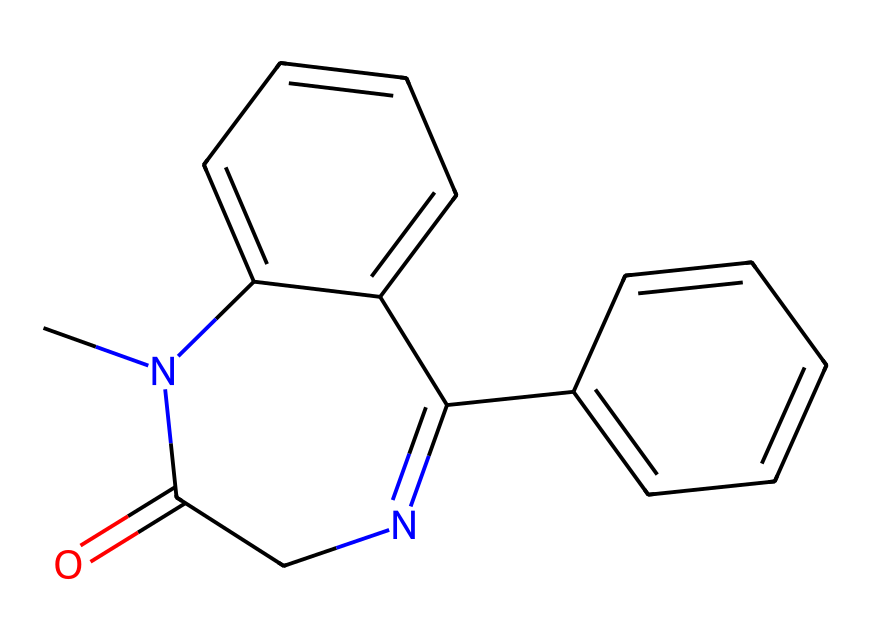What is the molecular formula of this compound? To determine the molecular formula, count the number of each type of atom in the SMILES. This chemical consists of 15 carbon atoms (C), 15 hydrogen atoms (H), 2 nitrogen atoms (N), and 2 oxygen atoms (O), resulting in the empirical formula C15H15N2O2.
Answer: C15H15N2O2 How many rings are present in the structure? In the SMILES representation, examine the numerals which indicate ring connections. There are three instances of '1', which shows that there are three rings formed in this structure.
Answer: 3 What type of chemical is represented by the SMILES? The structure indicates a benzodiazepine derivative, characterized by a benzene ring and a diazepine ring forming a significant element of its core structure used for anxiety treatment.
Answer: benzodiazepine How many nitrogen atoms are in the molecule? By examining the SMILES structure, we can count the nitrogen atoms. There are two nitrogen atoms indicated in the SMILES representation.
Answer: 2 Does this compound contain a phenyl group? The presence of the phenyl group can be observed through the structure where a benzene ring is attached to the main chain. This confirms that a phenyl group is indeed present.
Answer: yes What is the potential use of this compound in medicine? Given its structure resembles those of known benzodiazepines, it is likely used for anxiety. Medicinal chemists often analyze similar compounds for indications in treating anxiety disorders.
Answer: anxiety treatment 